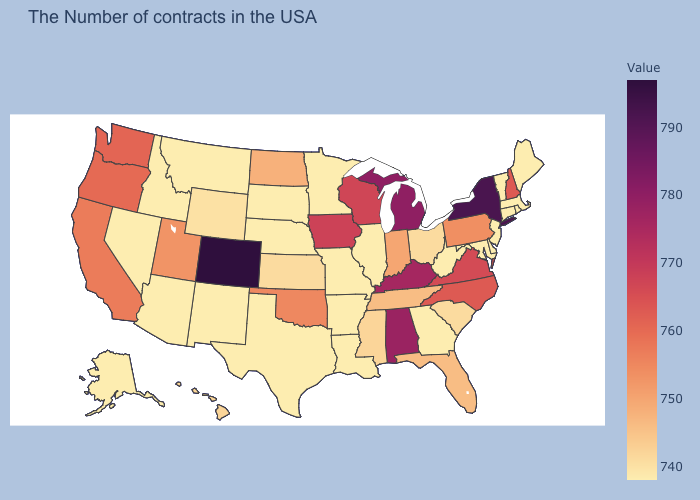Among the states that border Texas , does Arkansas have the lowest value?
Answer briefly. Yes. Which states have the highest value in the USA?
Give a very brief answer. Colorado. Which states have the highest value in the USA?
Short answer required. Colorado. Does Rhode Island have the lowest value in the Northeast?
Concise answer only. Yes. Does the map have missing data?
Give a very brief answer. No. 